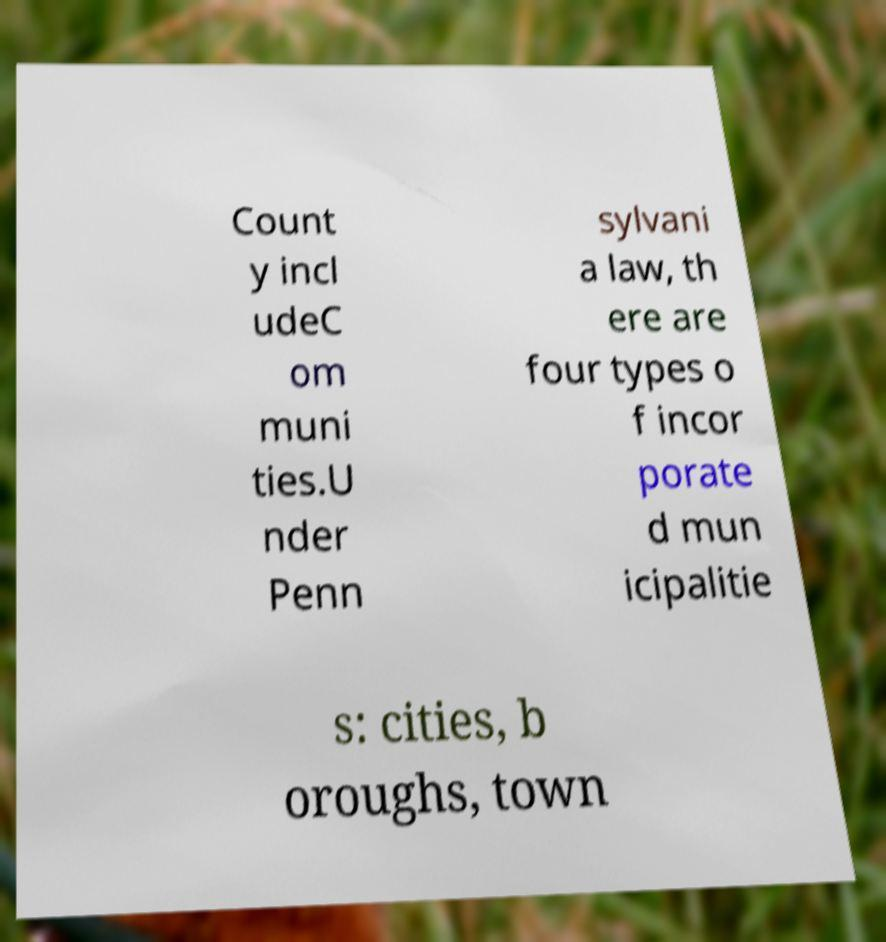Can you accurately transcribe the text from the provided image for me? Count y incl udeC om muni ties.U nder Penn sylvani a law, th ere are four types o f incor porate d mun icipalitie s: cities, b oroughs, town 